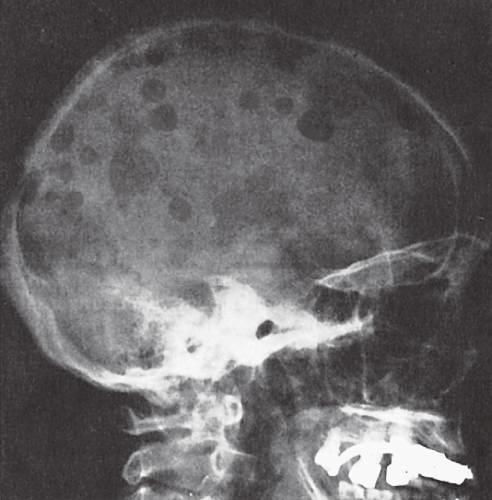re t_h2 cells most obvious in the calvaria?
Answer the question using a single word or phrase. No 